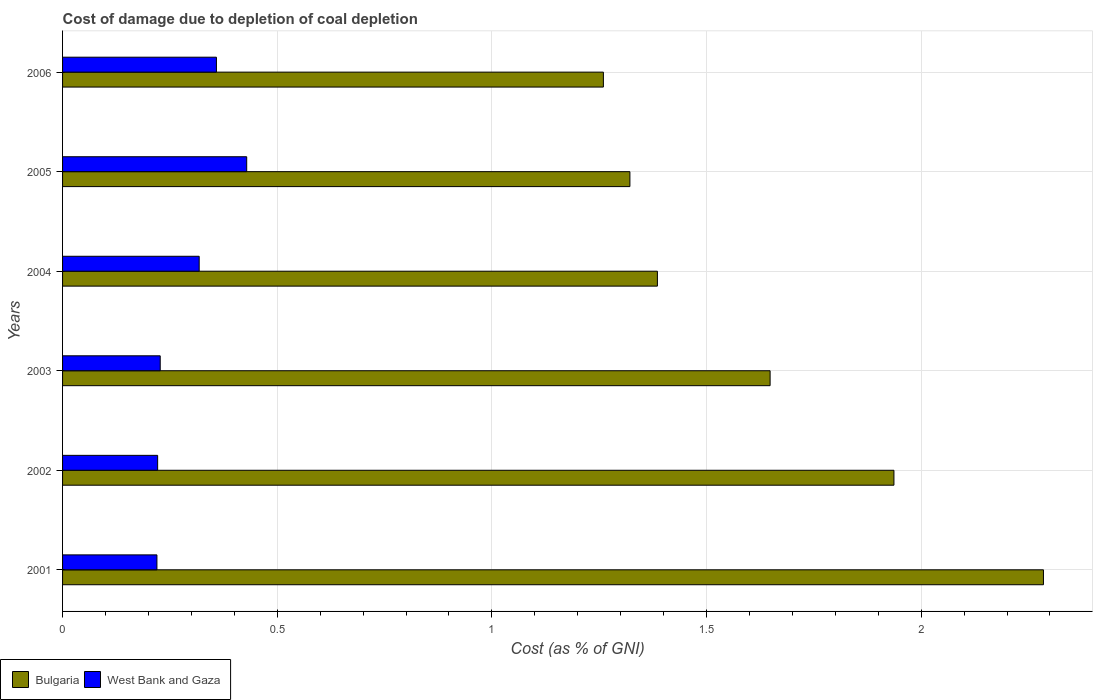How many different coloured bars are there?
Offer a terse response. 2. Are the number of bars per tick equal to the number of legend labels?
Provide a short and direct response. Yes. What is the label of the 5th group of bars from the top?
Your response must be concise. 2002. In how many cases, is the number of bars for a given year not equal to the number of legend labels?
Provide a short and direct response. 0. What is the cost of damage caused due to coal depletion in West Bank and Gaza in 2005?
Ensure brevity in your answer.  0.43. Across all years, what is the maximum cost of damage caused due to coal depletion in West Bank and Gaza?
Your response must be concise. 0.43. Across all years, what is the minimum cost of damage caused due to coal depletion in West Bank and Gaza?
Provide a succinct answer. 0.22. In which year was the cost of damage caused due to coal depletion in West Bank and Gaza minimum?
Your response must be concise. 2001. What is the total cost of damage caused due to coal depletion in West Bank and Gaza in the graph?
Provide a succinct answer. 1.77. What is the difference between the cost of damage caused due to coal depletion in Bulgaria in 2003 and that in 2004?
Give a very brief answer. 0.26. What is the difference between the cost of damage caused due to coal depletion in Bulgaria in 2004 and the cost of damage caused due to coal depletion in West Bank and Gaza in 2005?
Provide a short and direct response. 0.96. What is the average cost of damage caused due to coal depletion in West Bank and Gaza per year?
Your response must be concise. 0.3. In the year 2003, what is the difference between the cost of damage caused due to coal depletion in Bulgaria and cost of damage caused due to coal depletion in West Bank and Gaza?
Give a very brief answer. 1.42. In how many years, is the cost of damage caused due to coal depletion in West Bank and Gaza greater than 0.30000000000000004 %?
Offer a very short reply. 3. What is the ratio of the cost of damage caused due to coal depletion in Bulgaria in 2004 to that in 2006?
Your answer should be very brief. 1.1. Is the cost of damage caused due to coal depletion in West Bank and Gaza in 2001 less than that in 2003?
Make the answer very short. Yes. What is the difference between the highest and the second highest cost of damage caused due to coal depletion in West Bank and Gaza?
Provide a short and direct response. 0.07. What is the difference between the highest and the lowest cost of damage caused due to coal depletion in West Bank and Gaza?
Give a very brief answer. 0.21. Is the sum of the cost of damage caused due to coal depletion in West Bank and Gaza in 2002 and 2006 greater than the maximum cost of damage caused due to coal depletion in Bulgaria across all years?
Your answer should be very brief. No. What does the 2nd bar from the top in 2005 represents?
Offer a very short reply. Bulgaria. What does the 1st bar from the bottom in 2003 represents?
Offer a terse response. Bulgaria. How many bars are there?
Your answer should be compact. 12. How many years are there in the graph?
Make the answer very short. 6. What is the difference between two consecutive major ticks on the X-axis?
Give a very brief answer. 0.5. Are the values on the major ticks of X-axis written in scientific E-notation?
Ensure brevity in your answer.  No. Does the graph contain any zero values?
Give a very brief answer. No. Does the graph contain grids?
Keep it short and to the point. Yes. Where does the legend appear in the graph?
Provide a short and direct response. Bottom left. What is the title of the graph?
Keep it short and to the point. Cost of damage due to depletion of coal depletion. What is the label or title of the X-axis?
Offer a very short reply. Cost (as % of GNI). What is the Cost (as % of GNI) in Bulgaria in 2001?
Ensure brevity in your answer.  2.28. What is the Cost (as % of GNI) of West Bank and Gaza in 2001?
Your answer should be compact. 0.22. What is the Cost (as % of GNI) of Bulgaria in 2002?
Your answer should be compact. 1.94. What is the Cost (as % of GNI) of West Bank and Gaza in 2002?
Keep it short and to the point. 0.22. What is the Cost (as % of GNI) of Bulgaria in 2003?
Give a very brief answer. 1.65. What is the Cost (as % of GNI) in West Bank and Gaza in 2003?
Ensure brevity in your answer.  0.23. What is the Cost (as % of GNI) of Bulgaria in 2004?
Provide a succinct answer. 1.39. What is the Cost (as % of GNI) of West Bank and Gaza in 2004?
Give a very brief answer. 0.32. What is the Cost (as % of GNI) of Bulgaria in 2005?
Your response must be concise. 1.32. What is the Cost (as % of GNI) in West Bank and Gaza in 2005?
Your response must be concise. 0.43. What is the Cost (as % of GNI) in Bulgaria in 2006?
Ensure brevity in your answer.  1.26. What is the Cost (as % of GNI) of West Bank and Gaza in 2006?
Make the answer very short. 0.36. Across all years, what is the maximum Cost (as % of GNI) in Bulgaria?
Ensure brevity in your answer.  2.28. Across all years, what is the maximum Cost (as % of GNI) of West Bank and Gaza?
Give a very brief answer. 0.43. Across all years, what is the minimum Cost (as % of GNI) of Bulgaria?
Your response must be concise. 1.26. Across all years, what is the minimum Cost (as % of GNI) of West Bank and Gaza?
Give a very brief answer. 0.22. What is the total Cost (as % of GNI) of Bulgaria in the graph?
Give a very brief answer. 9.84. What is the total Cost (as % of GNI) of West Bank and Gaza in the graph?
Your response must be concise. 1.77. What is the difference between the Cost (as % of GNI) in Bulgaria in 2001 and that in 2002?
Offer a very short reply. 0.35. What is the difference between the Cost (as % of GNI) in West Bank and Gaza in 2001 and that in 2002?
Provide a short and direct response. -0. What is the difference between the Cost (as % of GNI) in Bulgaria in 2001 and that in 2003?
Provide a short and direct response. 0.64. What is the difference between the Cost (as % of GNI) in West Bank and Gaza in 2001 and that in 2003?
Make the answer very short. -0.01. What is the difference between the Cost (as % of GNI) of Bulgaria in 2001 and that in 2004?
Give a very brief answer. 0.9. What is the difference between the Cost (as % of GNI) in West Bank and Gaza in 2001 and that in 2004?
Provide a succinct answer. -0.1. What is the difference between the Cost (as % of GNI) of Bulgaria in 2001 and that in 2005?
Make the answer very short. 0.96. What is the difference between the Cost (as % of GNI) of West Bank and Gaza in 2001 and that in 2005?
Your answer should be very brief. -0.21. What is the difference between the Cost (as % of GNI) in Bulgaria in 2001 and that in 2006?
Offer a very short reply. 1.03. What is the difference between the Cost (as % of GNI) of West Bank and Gaza in 2001 and that in 2006?
Offer a very short reply. -0.14. What is the difference between the Cost (as % of GNI) of Bulgaria in 2002 and that in 2003?
Your answer should be compact. 0.29. What is the difference between the Cost (as % of GNI) in West Bank and Gaza in 2002 and that in 2003?
Offer a terse response. -0.01. What is the difference between the Cost (as % of GNI) of Bulgaria in 2002 and that in 2004?
Give a very brief answer. 0.55. What is the difference between the Cost (as % of GNI) of West Bank and Gaza in 2002 and that in 2004?
Provide a short and direct response. -0.1. What is the difference between the Cost (as % of GNI) of Bulgaria in 2002 and that in 2005?
Give a very brief answer. 0.61. What is the difference between the Cost (as % of GNI) in West Bank and Gaza in 2002 and that in 2005?
Your answer should be compact. -0.21. What is the difference between the Cost (as % of GNI) in Bulgaria in 2002 and that in 2006?
Your response must be concise. 0.68. What is the difference between the Cost (as % of GNI) of West Bank and Gaza in 2002 and that in 2006?
Give a very brief answer. -0.14. What is the difference between the Cost (as % of GNI) in Bulgaria in 2003 and that in 2004?
Offer a terse response. 0.26. What is the difference between the Cost (as % of GNI) in West Bank and Gaza in 2003 and that in 2004?
Your answer should be compact. -0.09. What is the difference between the Cost (as % of GNI) of Bulgaria in 2003 and that in 2005?
Make the answer very short. 0.33. What is the difference between the Cost (as % of GNI) in West Bank and Gaza in 2003 and that in 2005?
Offer a terse response. -0.2. What is the difference between the Cost (as % of GNI) in Bulgaria in 2003 and that in 2006?
Make the answer very short. 0.39. What is the difference between the Cost (as % of GNI) of West Bank and Gaza in 2003 and that in 2006?
Keep it short and to the point. -0.13. What is the difference between the Cost (as % of GNI) of Bulgaria in 2004 and that in 2005?
Provide a short and direct response. 0.06. What is the difference between the Cost (as % of GNI) in West Bank and Gaza in 2004 and that in 2005?
Provide a succinct answer. -0.11. What is the difference between the Cost (as % of GNI) in Bulgaria in 2004 and that in 2006?
Provide a short and direct response. 0.13. What is the difference between the Cost (as % of GNI) in West Bank and Gaza in 2004 and that in 2006?
Your answer should be compact. -0.04. What is the difference between the Cost (as % of GNI) in Bulgaria in 2005 and that in 2006?
Give a very brief answer. 0.06. What is the difference between the Cost (as % of GNI) of West Bank and Gaza in 2005 and that in 2006?
Offer a very short reply. 0.07. What is the difference between the Cost (as % of GNI) of Bulgaria in 2001 and the Cost (as % of GNI) of West Bank and Gaza in 2002?
Provide a succinct answer. 2.06. What is the difference between the Cost (as % of GNI) in Bulgaria in 2001 and the Cost (as % of GNI) in West Bank and Gaza in 2003?
Make the answer very short. 2.06. What is the difference between the Cost (as % of GNI) of Bulgaria in 2001 and the Cost (as % of GNI) of West Bank and Gaza in 2004?
Give a very brief answer. 1.97. What is the difference between the Cost (as % of GNI) in Bulgaria in 2001 and the Cost (as % of GNI) in West Bank and Gaza in 2005?
Offer a terse response. 1.86. What is the difference between the Cost (as % of GNI) in Bulgaria in 2001 and the Cost (as % of GNI) in West Bank and Gaza in 2006?
Give a very brief answer. 1.93. What is the difference between the Cost (as % of GNI) of Bulgaria in 2002 and the Cost (as % of GNI) of West Bank and Gaza in 2003?
Give a very brief answer. 1.71. What is the difference between the Cost (as % of GNI) in Bulgaria in 2002 and the Cost (as % of GNI) in West Bank and Gaza in 2004?
Provide a succinct answer. 1.62. What is the difference between the Cost (as % of GNI) in Bulgaria in 2002 and the Cost (as % of GNI) in West Bank and Gaza in 2005?
Keep it short and to the point. 1.51. What is the difference between the Cost (as % of GNI) of Bulgaria in 2002 and the Cost (as % of GNI) of West Bank and Gaza in 2006?
Give a very brief answer. 1.58. What is the difference between the Cost (as % of GNI) in Bulgaria in 2003 and the Cost (as % of GNI) in West Bank and Gaza in 2004?
Your answer should be compact. 1.33. What is the difference between the Cost (as % of GNI) in Bulgaria in 2003 and the Cost (as % of GNI) in West Bank and Gaza in 2005?
Keep it short and to the point. 1.22. What is the difference between the Cost (as % of GNI) of Bulgaria in 2003 and the Cost (as % of GNI) of West Bank and Gaza in 2006?
Keep it short and to the point. 1.29. What is the difference between the Cost (as % of GNI) of Bulgaria in 2004 and the Cost (as % of GNI) of West Bank and Gaza in 2005?
Your answer should be very brief. 0.96. What is the difference between the Cost (as % of GNI) in Bulgaria in 2004 and the Cost (as % of GNI) in West Bank and Gaza in 2006?
Your answer should be very brief. 1.03. What is the difference between the Cost (as % of GNI) in Bulgaria in 2005 and the Cost (as % of GNI) in West Bank and Gaza in 2006?
Make the answer very short. 0.96. What is the average Cost (as % of GNI) in Bulgaria per year?
Give a very brief answer. 1.64. What is the average Cost (as % of GNI) of West Bank and Gaza per year?
Ensure brevity in your answer.  0.3. In the year 2001, what is the difference between the Cost (as % of GNI) of Bulgaria and Cost (as % of GNI) of West Bank and Gaza?
Your answer should be very brief. 2.07. In the year 2002, what is the difference between the Cost (as % of GNI) in Bulgaria and Cost (as % of GNI) in West Bank and Gaza?
Offer a very short reply. 1.72. In the year 2003, what is the difference between the Cost (as % of GNI) in Bulgaria and Cost (as % of GNI) in West Bank and Gaza?
Keep it short and to the point. 1.42. In the year 2004, what is the difference between the Cost (as % of GNI) of Bulgaria and Cost (as % of GNI) of West Bank and Gaza?
Keep it short and to the point. 1.07. In the year 2005, what is the difference between the Cost (as % of GNI) of Bulgaria and Cost (as % of GNI) of West Bank and Gaza?
Offer a very short reply. 0.89. In the year 2006, what is the difference between the Cost (as % of GNI) in Bulgaria and Cost (as % of GNI) in West Bank and Gaza?
Your response must be concise. 0.9. What is the ratio of the Cost (as % of GNI) in Bulgaria in 2001 to that in 2002?
Give a very brief answer. 1.18. What is the ratio of the Cost (as % of GNI) in Bulgaria in 2001 to that in 2003?
Give a very brief answer. 1.39. What is the ratio of the Cost (as % of GNI) of West Bank and Gaza in 2001 to that in 2003?
Provide a succinct answer. 0.97. What is the ratio of the Cost (as % of GNI) of Bulgaria in 2001 to that in 2004?
Provide a succinct answer. 1.65. What is the ratio of the Cost (as % of GNI) of West Bank and Gaza in 2001 to that in 2004?
Provide a succinct answer. 0.69. What is the ratio of the Cost (as % of GNI) in Bulgaria in 2001 to that in 2005?
Offer a very short reply. 1.73. What is the ratio of the Cost (as % of GNI) in West Bank and Gaza in 2001 to that in 2005?
Your response must be concise. 0.51. What is the ratio of the Cost (as % of GNI) of Bulgaria in 2001 to that in 2006?
Offer a terse response. 1.81. What is the ratio of the Cost (as % of GNI) of West Bank and Gaza in 2001 to that in 2006?
Offer a terse response. 0.61. What is the ratio of the Cost (as % of GNI) of Bulgaria in 2002 to that in 2003?
Offer a terse response. 1.18. What is the ratio of the Cost (as % of GNI) of West Bank and Gaza in 2002 to that in 2003?
Your response must be concise. 0.97. What is the ratio of the Cost (as % of GNI) of Bulgaria in 2002 to that in 2004?
Your answer should be compact. 1.4. What is the ratio of the Cost (as % of GNI) in West Bank and Gaza in 2002 to that in 2004?
Offer a very short reply. 0.7. What is the ratio of the Cost (as % of GNI) in Bulgaria in 2002 to that in 2005?
Provide a short and direct response. 1.47. What is the ratio of the Cost (as % of GNI) of West Bank and Gaza in 2002 to that in 2005?
Keep it short and to the point. 0.52. What is the ratio of the Cost (as % of GNI) of Bulgaria in 2002 to that in 2006?
Provide a short and direct response. 1.54. What is the ratio of the Cost (as % of GNI) in West Bank and Gaza in 2002 to that in 2006?
Your answer should be very brief. 0.62. What is the ratio of the Cost (as % of GNI) of Bulgaria in 2003 to that in 2004?
Your answer should be compact. 1.19. What is the ratio of the Cost (as % of GNI) of West Bank and Gaza in 2003 to that in 2004?
Provide a succinct answer. 0.71. What is the ratio of the Cost (as % of GNI) of Bulgaria in 2003 to that in 2005?
Your answer should be compact. 1.25. What is the ratio of the Cost (as % of GNI) of West Bank and Gaza in 2003 to that in 2005?
Your response must be concise. 0.53. What is the ratio of the Cost (as % of GNI) of Bulgaria in 2003 to that in 2006?
Your answer should be compact. 1.31. What is the ratio of the Cost (as % of GNI) of West Bank and Gaza in 2003 to that in 2006?
Provide a succinct answer. 0.63. What is the ratio of the Cost (as % of GNI) of Bulgaria in 2004 to that in 2005?
Your answer should be compact. 1.05. What is the ratio of the Cost (as % of GNI) in West Bank and Gaza in 2004 to that in 2005?
Offer a very short reply. 0.74. What is the ratio of the Cost (as % of GNI) of Bulgaria in 2004 to that in 2006?
Give a very brief answer. 1.1. What is the ratio of the Cost (as % of GNI) in West Bank and Gaza in 2004 to that in 2006?
Make the answer very short. 0.89. What is the ratio of the Cost (as % of GNI) in Bulgaria in 2005 to that in 2006?
Provide a short and direct response. 1.05. What is the ratio of the Cost (as % of GNI) of West Bank and Gaza in 2005 to that in 2006?
Provide a succinct answer. 1.2. What is the difference between the highest and the second highest Cost (as % of GNI) in Bulgaria?
Your response must be concise. 0.35. What is the difference between the highest and the second highest Cost (as % of GNI) of West Bank and Gaza?
Your response must be concise. 0.07. What is the difference between the highest and the lowest Cost (as % of GNI) of Bulgaria?
Your answer should be compact. 1.03. What is the difference between the highest and the lowest Cost (as % of GNI) in West Bank and Gaza?
Offer a very short reply. 0.21. 